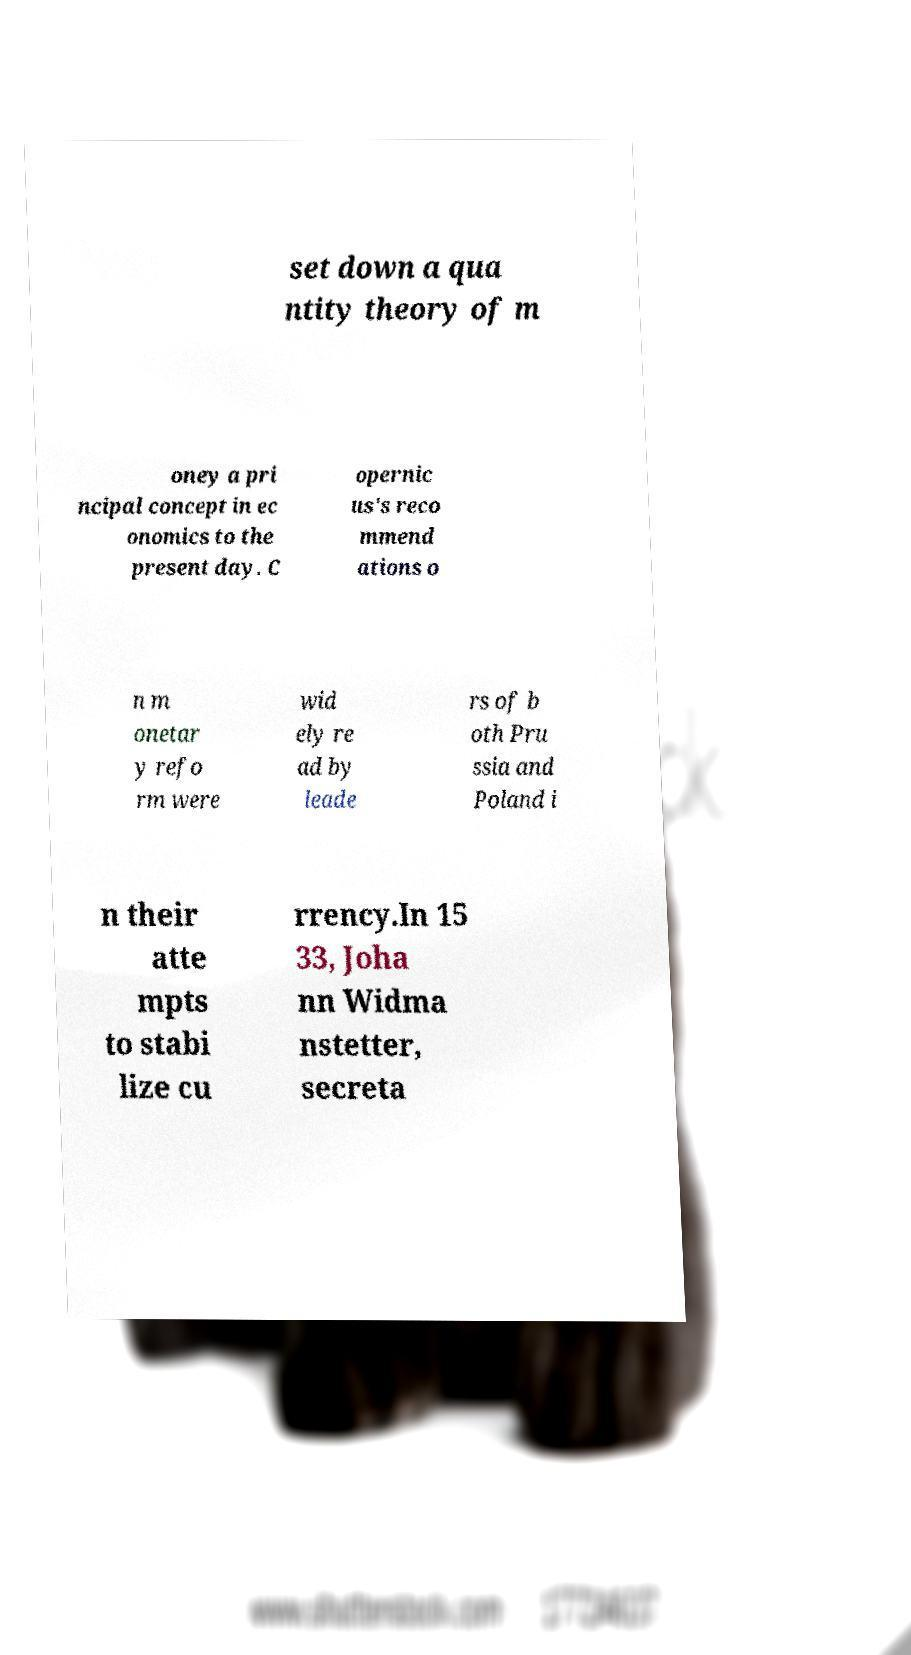Please identify and transcribe the text found in this image. set down a qua ntity theory of m oney a pri ncipal concept in ec onomics to the present day. C opernic us's reco mmend ations o n m onetar y refo rm were wid ely re ad by leade rs of b oth Pru ssia and Poland i n their atte mpts to stabi lize cu rrency.In 15 33, Joha nn Widma nstetter, secreta 